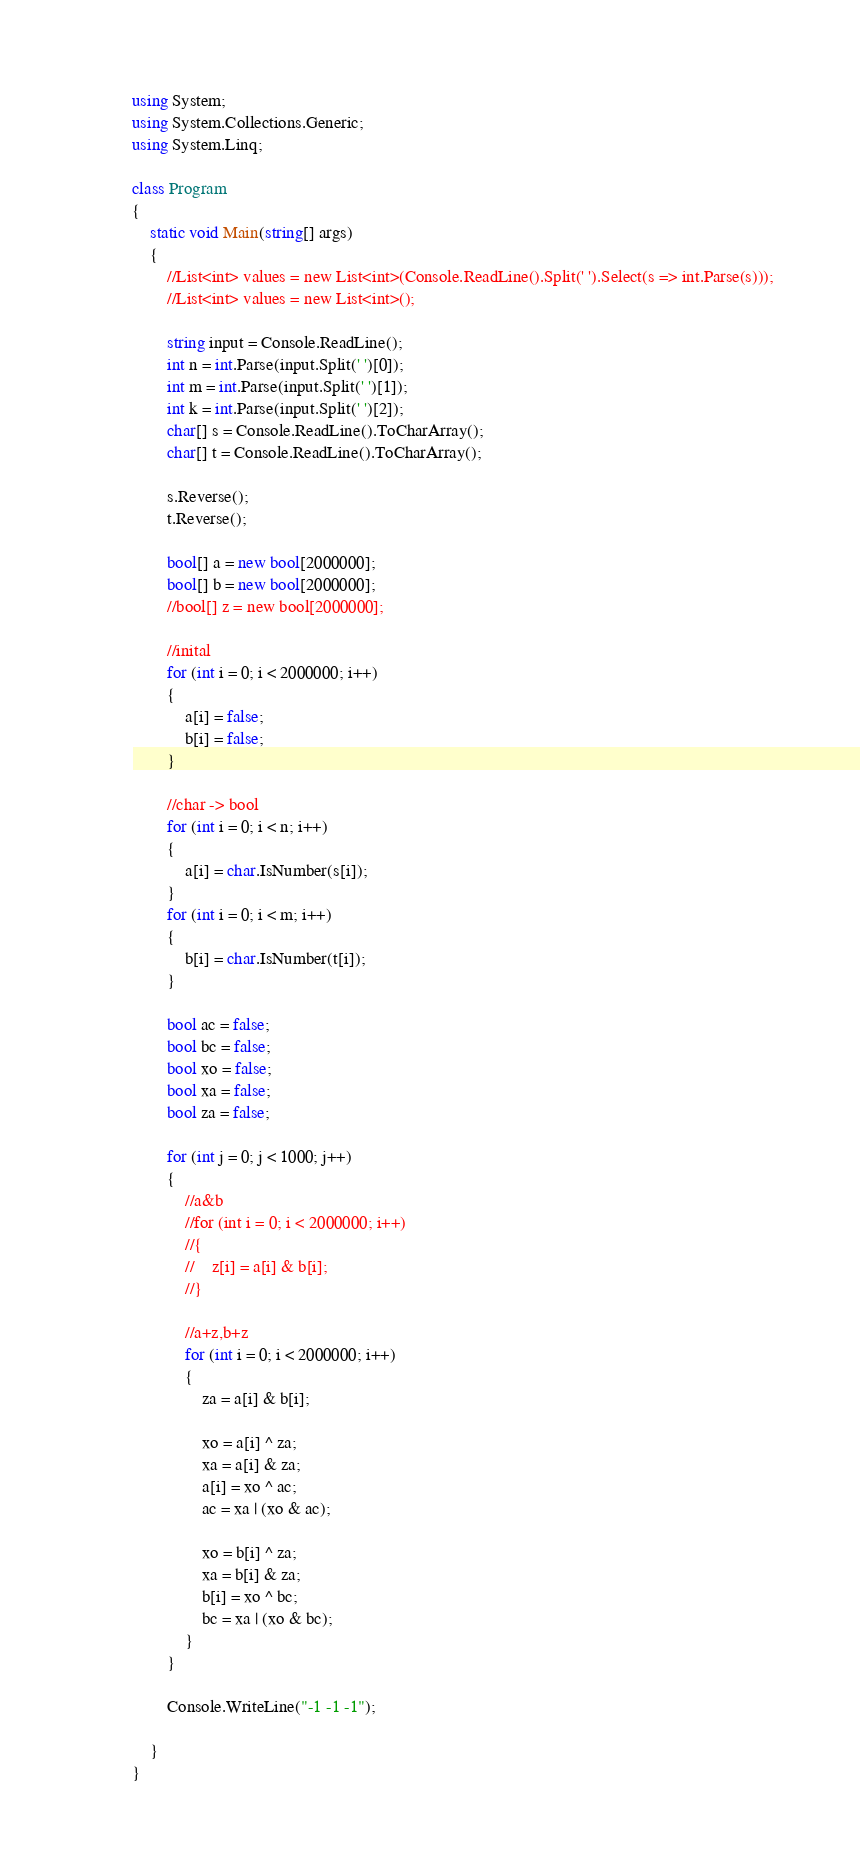<code> <loc_0><loc_0><loc_500><loc_500><_C#_>
using System;
using System.Collections.Generic;
using System.Linq;

class Program
{
    static void Main(string[] args)
    {
        //List<int> values = new List<int>(Console.ReadLine().Split(' ').Select(s => int.Parse(s)));
        //List<int> values = new List<int>();

        string input = Console.ReadLine();
        int n = int.Parse(input.Split(' ')[0]);
        int m = int.Parse(input.Split(' ')[1]);
        int k = int.Parse(input.Split(' ')[2]);
        char[] s = Console.ReadLine().ToCharArray();
        char[] t = Console.ReadLine().ToCharArray();

        s.Reverse();
        t.Reverse();

        bool[] a = new bool[2000000];
        bool[] b = new bool[2000000];
        //bool[] z = new bool[2000000];

        //inital
        for (int i = 0; i < 2000000; i++)
        {
            a[i] = false;
            b[i] = false;
        }

        //char -> bool
        for (int i = 0; i < n; i++)
        {
            a[i] = char.IsNumber(s[i]);
        }
        for (int i = 0; i < m; i++)
        {
            b[i] = char.IsNumber(t[i]);
        }

        bool ac = false;
        bool bc = false;
        bool xo = false;
        bool xa = false;
        bool za = false;

        for (int j = 0; j < 1000; j++)
        {
            //a&b
            //for (int i = 0; i < 2000000; i++)
            //{
            //    z[i] = a[i] & b[i];
            //}

            //a+z,b+z
            for (int i = 0; i < 2000000; i++)
            {
                za = a[i] & b[i];

                xo = a[i] ^ za;
                xa = a[i] & za;
                a[i] = xo ^ ac;
                ac = xa | (xo & ac);

                xo = b[i] ^ za;
                xa = b[i] & za;
                b[i] = xo ^ bc;
                bc = xa | (xo & bc);
            }
        }

        Console.WriteLine("-1 -1 -1");

    }
}</code> 